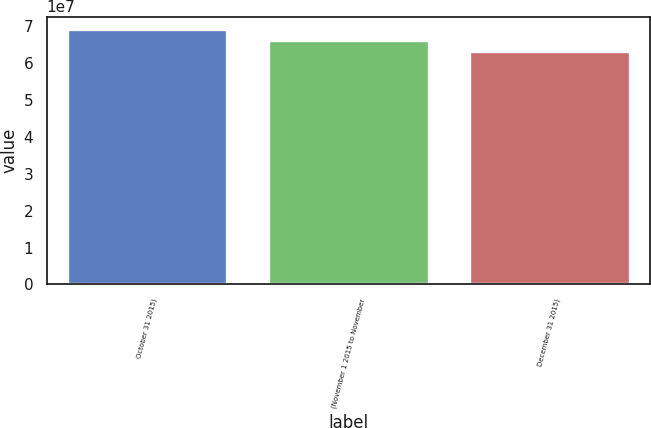Convert chart to OTSL. <chart><loc_0><loc_0><loc_500><loc_500><bar_chart><fcel>October 31 2015)<fcel>(November 1 2015 to November<fcel>December 31 2015)<nl><fcel>6.91643e+07<fcel>6.62493e+07<fcel>6.32019e+07<nl></chart> 